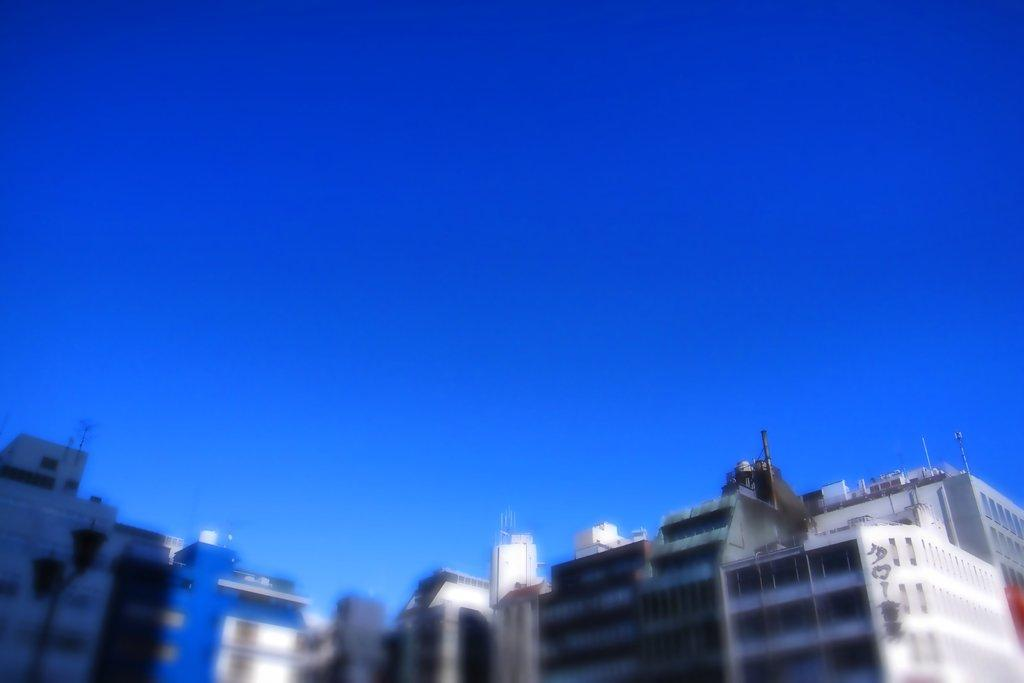What type of structures can be seen in the image? There are many buildings in the image. What part of the natural environment is visible in the image? The sky is visible in the image. What is the color of the sky in the image? The color of the sky is blue. How would you describe the clarity of the image? The image is blurred. Where are the bushes located in the image? There are no bushes present in the image. Can you see any ducks swimming in the sky in the image? There are no ducks present in the image, and the sky is not depicted as a body of water. 